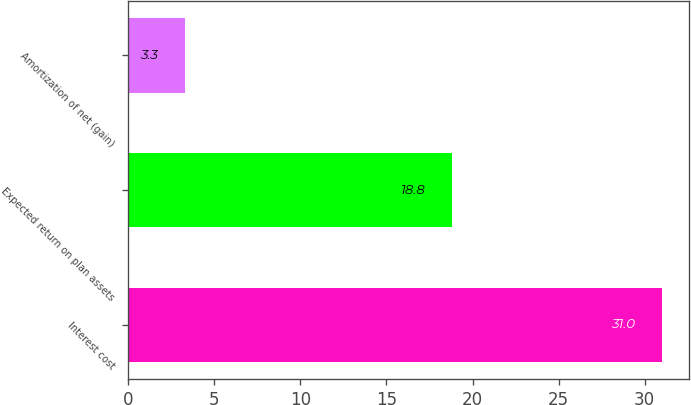Convert chart to OTSL. <chart><loc_0><loc_0><loc_500><loc_500><bar_chart><fcel>Interest cost<fcel>Expected return on plan assets<fcel>Amortization of net (gain)<nl><fcel>31<fcel>18.8<fcel>3.3<nl></chart> 